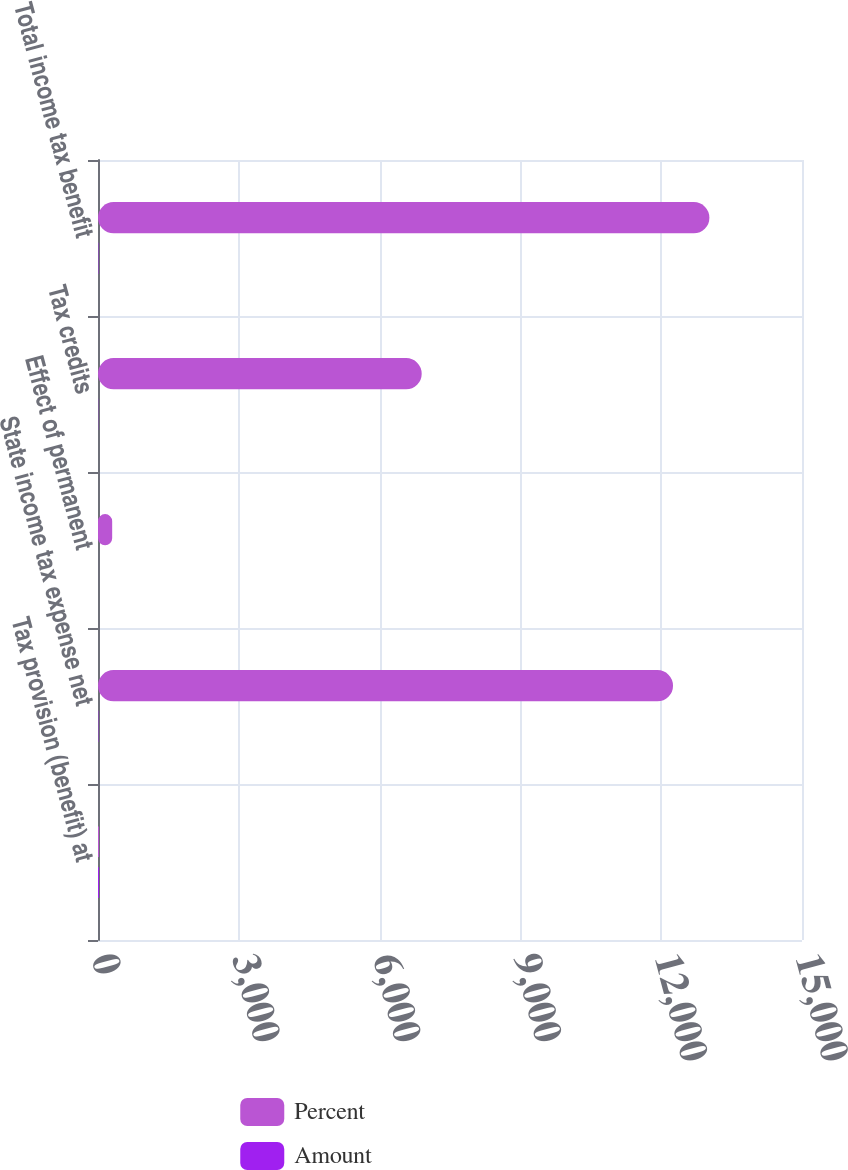<chart> <loc_0><loc_0><loc_500><loc_500><stacked_bar_chart><ecel><fcel>Tax provision (benefit) at<fcel>State income tax expense net<fcel>Effect of permanent<fcel>Tax credits<fcel>Total income tax benefit<nl><fcel>Percent<fcel>21<fcel>12252<fcel>302<fcel>6897<fcel>13027<nl><fcel>Amount<fcel>21<fcel>7.7<fcel>0.2<fcel>4.4<fcel>8.3<nl></chart> 